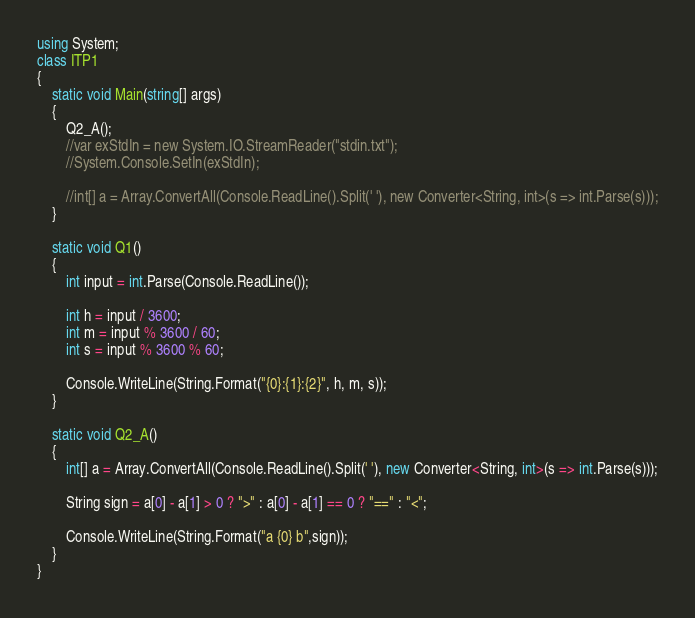Convert code to text. <code><loc_0><loc_0><loc_500><loc_500><_C#_>using System;
class ITP1
{
    static void Main(string[] args)
    {
        Q2_A();
        //var exStdIn = new System.IO.StreamReader("stdin.txt");
        //System.Console.SetIn(exStdIn);

        //int[] a = Array.ConvertAll(Console.ReadLine().Split(' '), new Converter<String, int>(s => int.Parse(s)));
    }

    static void Q1()
    {
        int input = int.Parse(Console.ReadLine());

        int h = input / 3600;
        int m = input % 3600 / 60;
        int s = input % 3600 % 60;

        Console.WriteLine(String.Format("{0}:{1}:{2}", h, m, s));
    }

    static void Q2_A()
    {
        int[] a = Array.ConvertAll(Console.ReadLine().Split(' '), new Converter<String, int>(s => int.Parse(s)));

        String sign = a[0] - a[1] > 0 ? ">" : a[0] - a[1] == 0 ? "==" : "<";

        Console.WriteLine(String.Format("a {0} b",sign));
    }
}</code> 